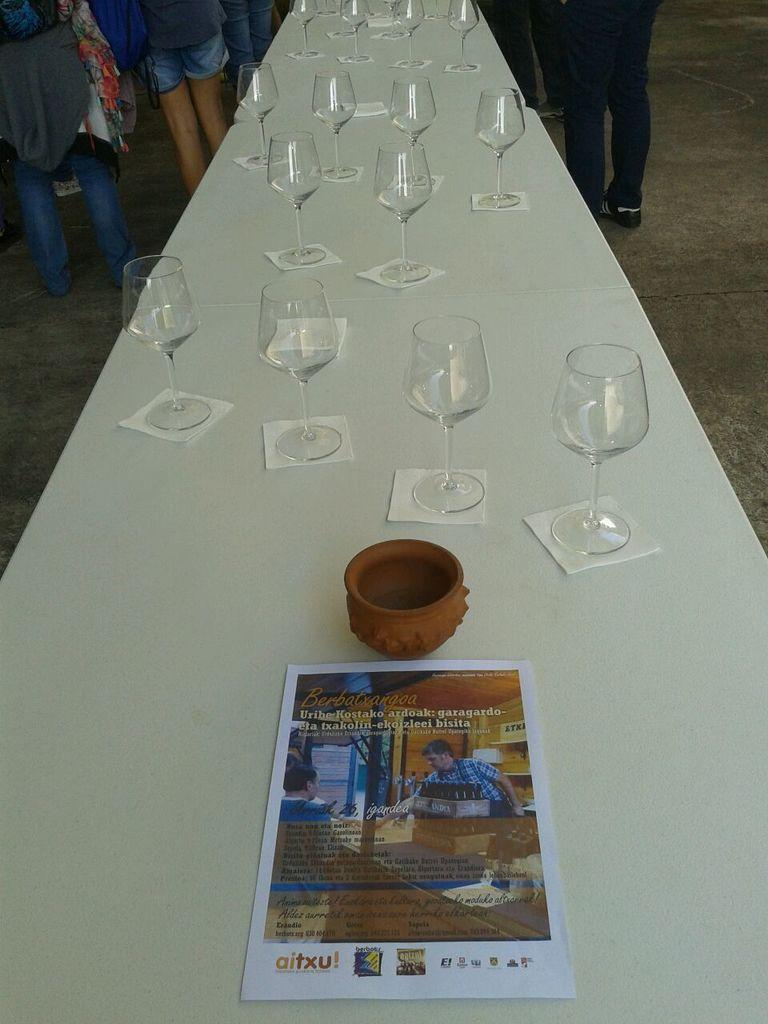How many people are in the image? There is a group of people in the image. What are the people doing in the image? The people are standing. Can you describe the clothing of one of the people? One person is wearing a scarf. What is on the table in the image? There is a table in the image with glasses, a bowl, and a poster on it. What type of soda is being served in the glasses on the table? There is no mention of soda in the image; only glasses, a bowl, and a poster are present on the table. What is the view outside the window in the image? There is no window or view mentioned in the image; it only features a group of people, their actions, and the table with its contents. 